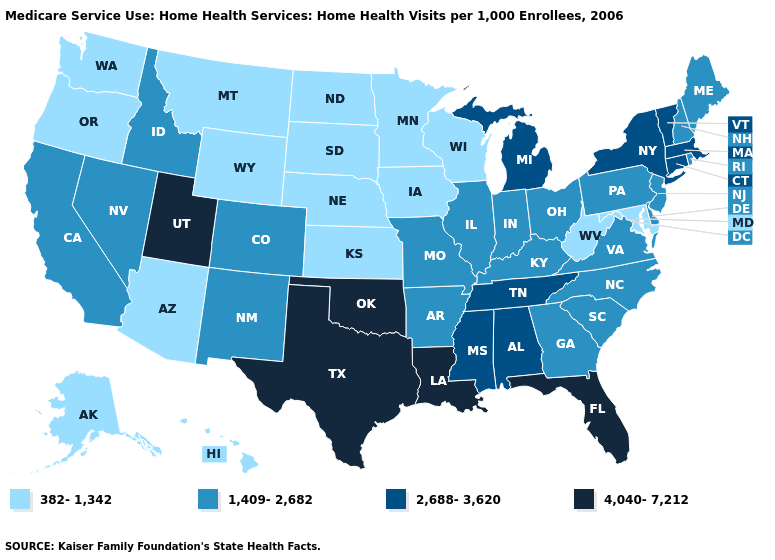What is the highest value in the West ?
Be succinct. 4,040-7,212. What is the value of New Mexico?
Answer briefly. 1,409-2,682. Name the states that have a value in the range 4,040-7,212?
Give a very brief answer. Florida, Louisiana, Oklahoma, Texas, Utah. Among the states that border Indiana , which have the lowest value?
Answer briefly. Illinois, Kentucky, Ohio. Name the states that have a value in the range 4,040-7,212?
Concise answer only. Florida, Louisiana, Oklahoma, Texas, Utah. What is the value of Idaho?
Answer briefly. 1,409-2,682. Name the states that have a value in the range 4,040-7,212?
Short answer required. Florida, Louisiana, Oklahoma, Texas, Utah. What is the lowest value in the MidWest?
Quick response, please. 382-1,342. What is the highest value in states that border California?
Write a very short answer. 1,409-2,682. Does Tennessee have a higher value than Utah?
Give a very brief answer. No. Among the states that border Michigan , does Wisconsin have the lowest value?
Answer briefly. Yes. What is the lowest value in states that border Nevada?
Write a very short answer. 382-1,342. What is the highest value in states that border Arkansas?
Answer briefly. 4,040-7,212. Is the legend a continuous bar?
Short answer required. No. Which states have the lowest value in the USA?
Be succinct. Alaska, Arizona, Hawaii, Iowa, Kansas, Maryland, Minnesota, Montana, Nebraska, North Dakota, Oregon, South Dakota, Washington, West Virginia, Wisconsin, Wyoming. 